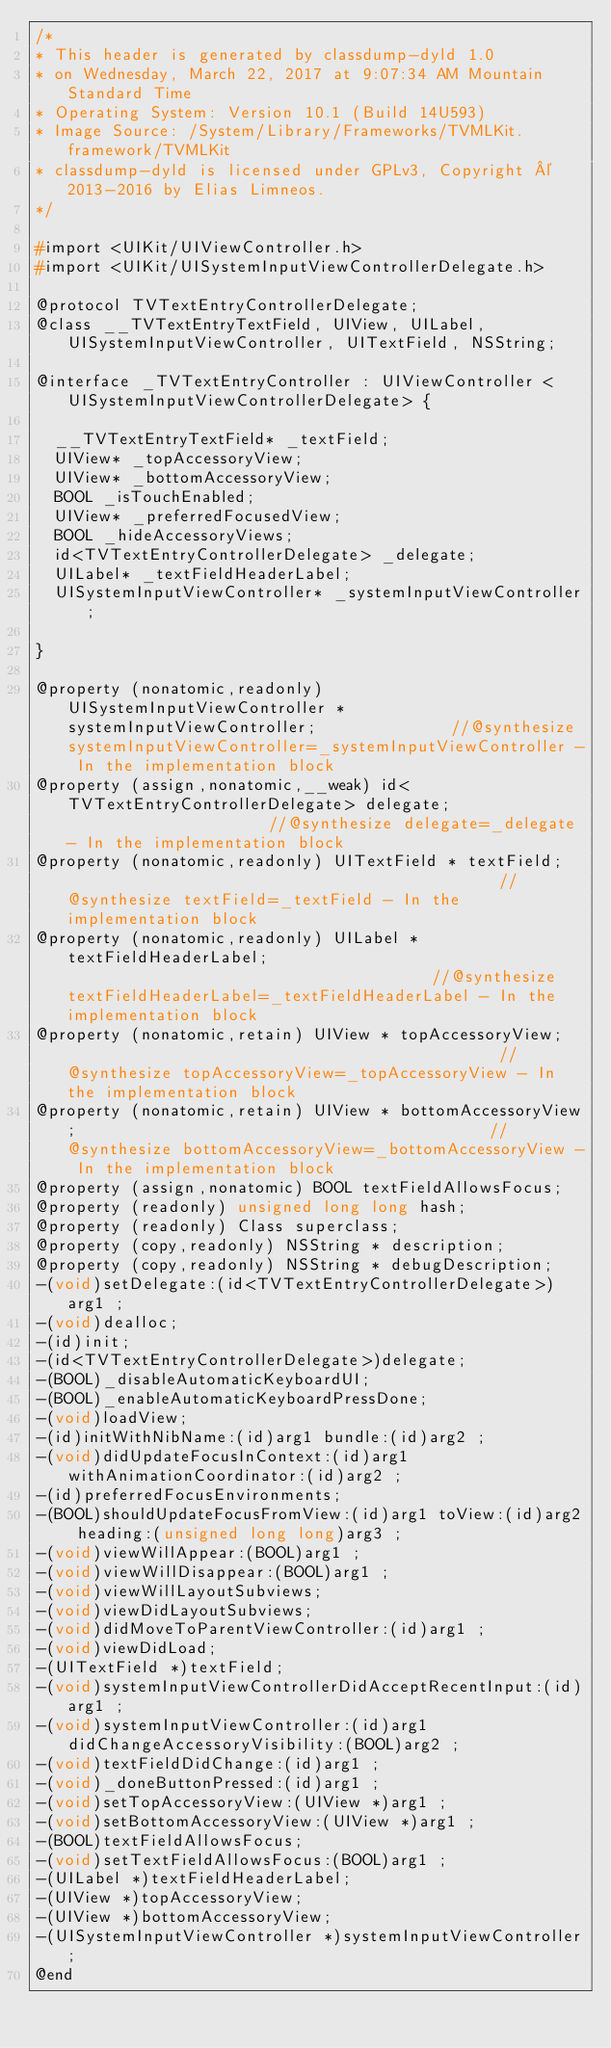<code> <loc_0><loc_0><loc_500><loc_500><_C_>/*
* This header is generated by classdump-dyld 1.0
* on Wednesday, March 22, 2017 at 9:07:34 AM Mountain Standard Time
* Operating System: Version 10.1 (Build 14U593)
* Image Source: /System/Library/Frameworks/TVMLKit.framework/TVMLKit
* classdump-dyld is licensed under GPLv3, Copyright © 2013-2016 by Elias Limneos.
*/

#import <UIKit/UIViewController.h>
#import <UIKit/UISystemInputViewControllerDelegate.h>

@protocol TVTextEntryControllerDelegate;
@class __TVTextEntryTextField, UIView, UILabel, UISystemInputViewController, UITextField, NSString;

@interface _TVTextEntryController : UIViewController <UISystemInputViewControllerDelegate> {

	__TVTextEntryTextField* _textField;
	UIView* _topAccessoryView;
	UIView* _bottomAccessoryView;
	BOOL _isTouchEnabled;
	UIView* _preferredFocusedView;
	BOOL _hideAccessoryViews;
	id<TVTextEntryControllerDelegate> _delegate;
	UILabel* _textFieldHeaderLabel;
	UISystemInputViewController* _systemInputViewController;

}

@property (nonatomic,readonly) UISystemInputViewController * systemInputViewController;              //@synthesize systemInputViewController=_systemInputViewController - In the implementation block
@property (assign,nonatomic,__weak) id<TVTextEntryControllerDelegate> delegate;                      //@synthesize delegate=_delegate - In the implementation block
@property (nonatomic,readonly) UITextField * textField;                                              //@synthesize textField=_textField - In the implementation block
@property (nonatomic,readonly) UILabel * textFieldHeaderLabel;                                       //@synthesize textFieldHeaderLabel=_textFieldHeaderLabel - In the implementation block
@property (nonatomic,retain) UIView * topAccessoryView;                                              //@synthesize topAccessoryView=_topAccessoryView - In the implementation block
@property (nonatomic,retain) UIView * bottomAccessoryView;                                           //@synthesize bottomAccessoryView=_bottomAccessoryView - In the implementation block
@property (assign,nonatomic) BOOL textFieldAllowsFocus; 
@property (readonly) unsigned long long hash; 
@property (readonly) Class superclass; 
@property (copy,readonly) NSString * description; 
@property (copy,readonly) NSString * debugDescription; 
-(void)setDelegate:(id<TVTextEntryControllerDelegate>)arg1 ;
-(void)dealloc;
-(id)init;
-(id<TVTextEntryControllerDelegate>)delegate;
-(BOOL)_disableAutomaticKeyboardUI;
-(BOOL)_enableAutomaticKeyboardPressDone;
-(void)loadView;
-(id)initWithNibName:(id)arg1 bundle:(id)arg2 ;
-(void)didUpdateFocusInContext:(id)arg1 withAnimationCoordinator:(id)arg2 ;
-(id)preferredFocusEnvironments;
-(BOOL)shouldUpdateFocusFromView:(id)arg1 toView:(id)arg2 heading:(unsigned long long)arg3 ;
-(void)viewWillAppear:(BOOL)arg1 ;
-(void)viewWillDisappear:(BOOL)arg1 ;
-(void)viewWillLayoutSubviews;
-(void)viewDidLayoutSubviews;
-(void)didMoveToParentViewController:(id)arg1 ;
-(void)viewDidLoad;
-(UITextField *)textField;
-(void)systemInputViewControllerDidAcceptRecentInput:(id)arg1 ;
-(void)systemInputViewController:(id)arg1 didChangeAccessoryVisibility:(BOOL)arg2 ;
-(void)textFieldDidChange:(id)arg1 ;
-(void)_doneButtonPressed:(id)arg1 ;
-(void)setTopAccessoryView:(UIView *)arg1 ;
-(void)setBottomAccessoryView:(UIView *)arg1 ;
-(BOOL)textFieldAllowsFocus;
-(void)setTextFieldAllowsFocus:(BOOL)arg1 ;
-(UILabel *)textFieldHeaderLabel;
-(UIView *)topAccessoryView;
-(UIView *)bottomAccessoryView;
-(UISystemInputViewController *)systemInputViewController;
@end

</code> 